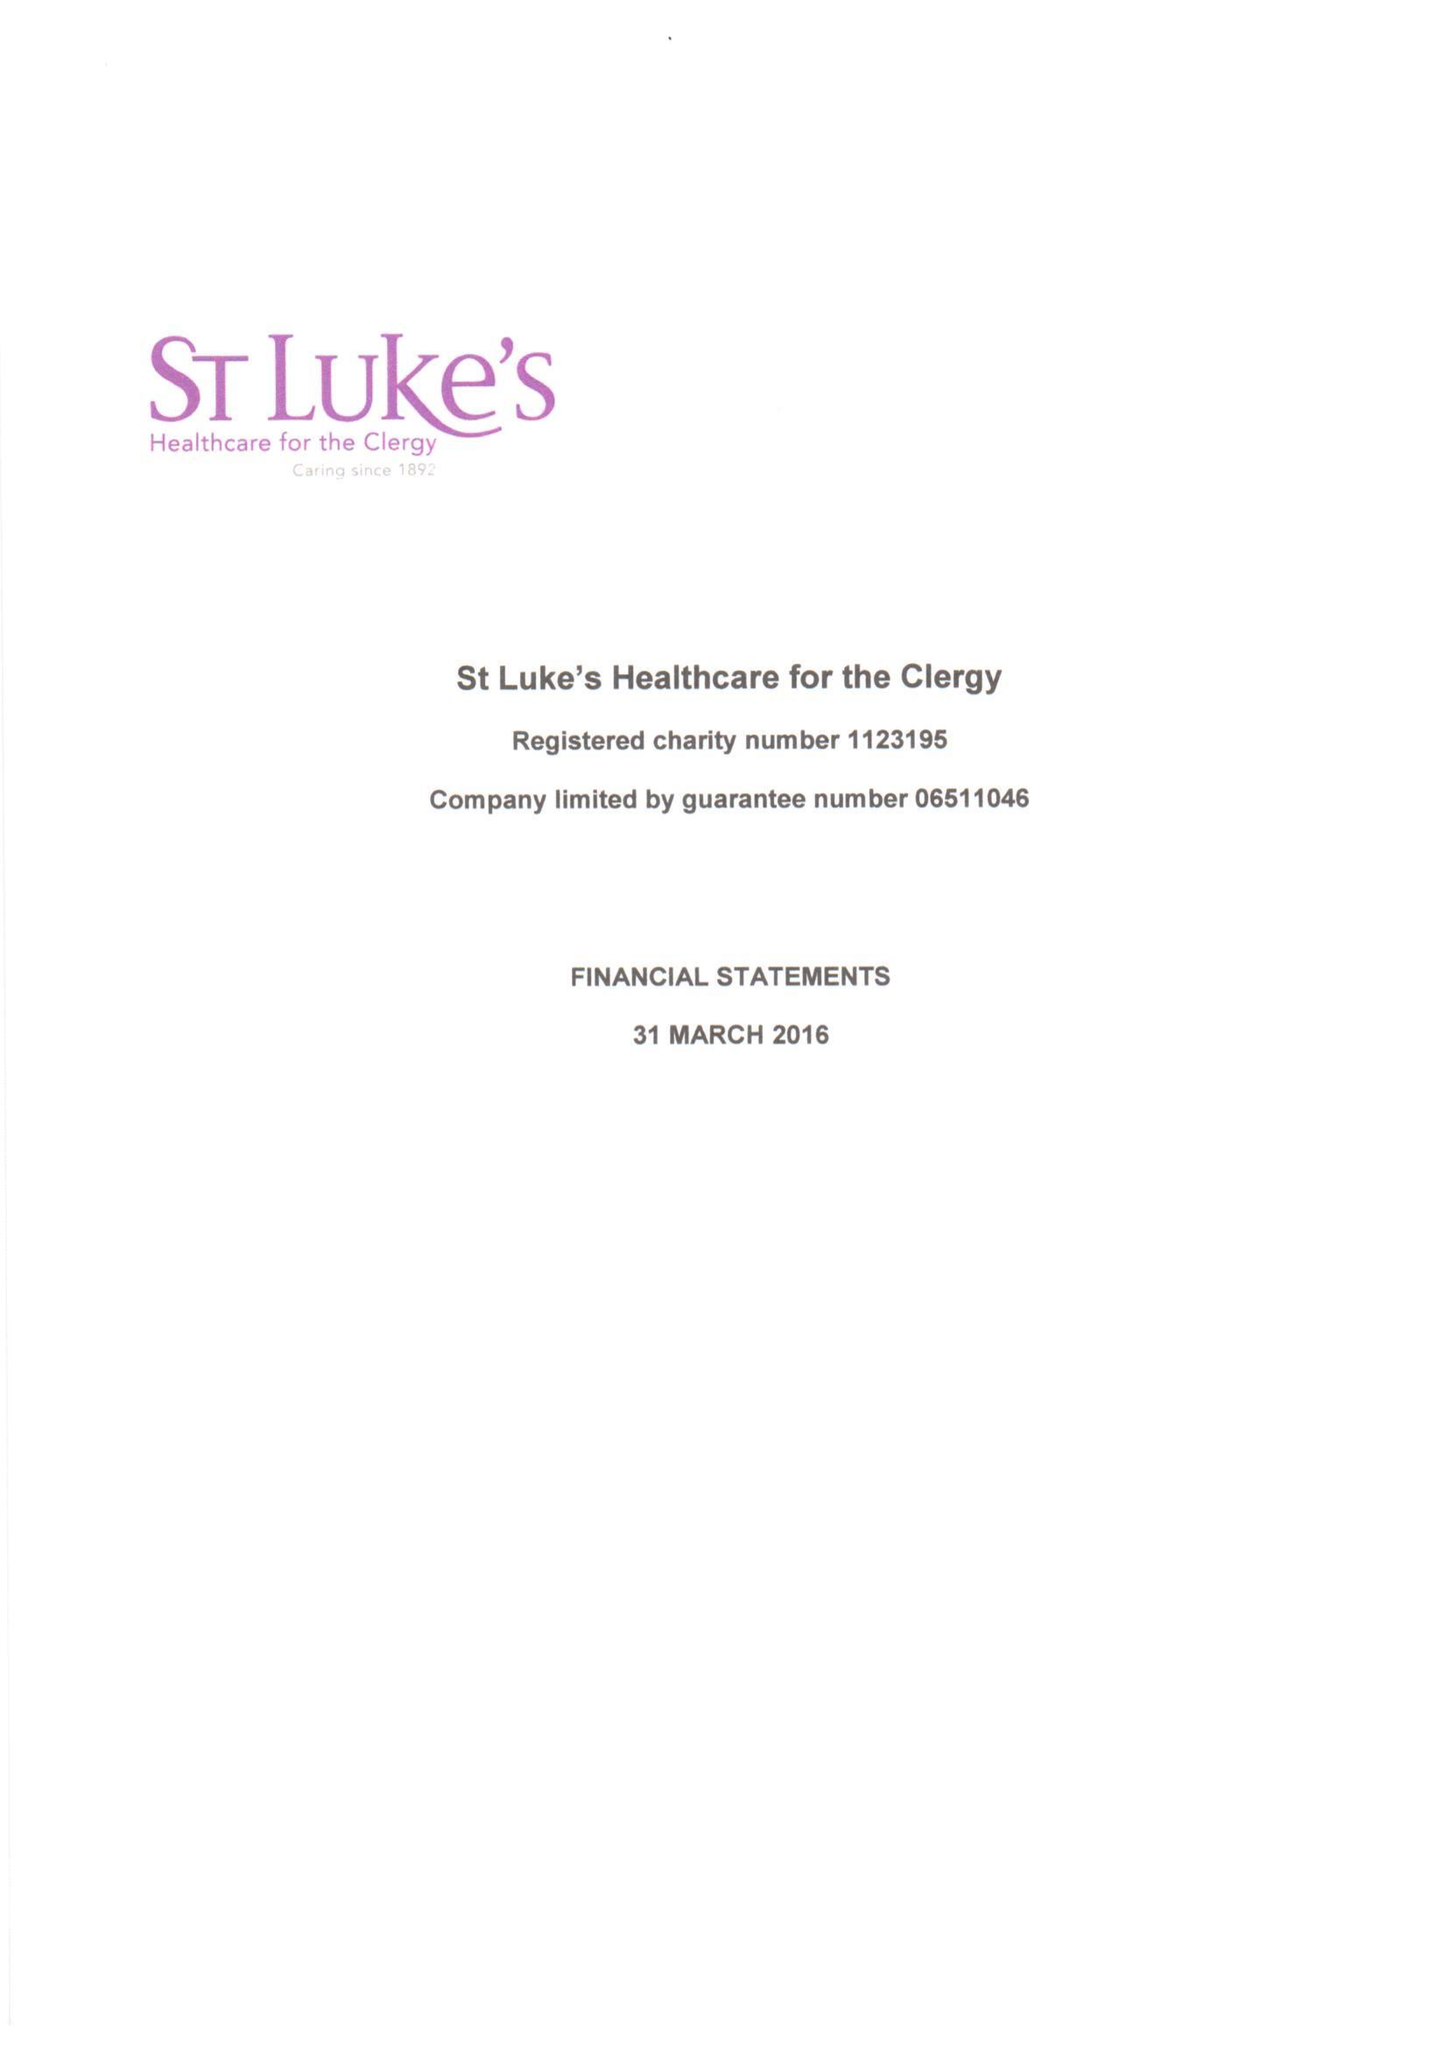What is the value for the charity_name?
Answer the question using a single word or phrase. St Luke's Healthcare For The Clergy 